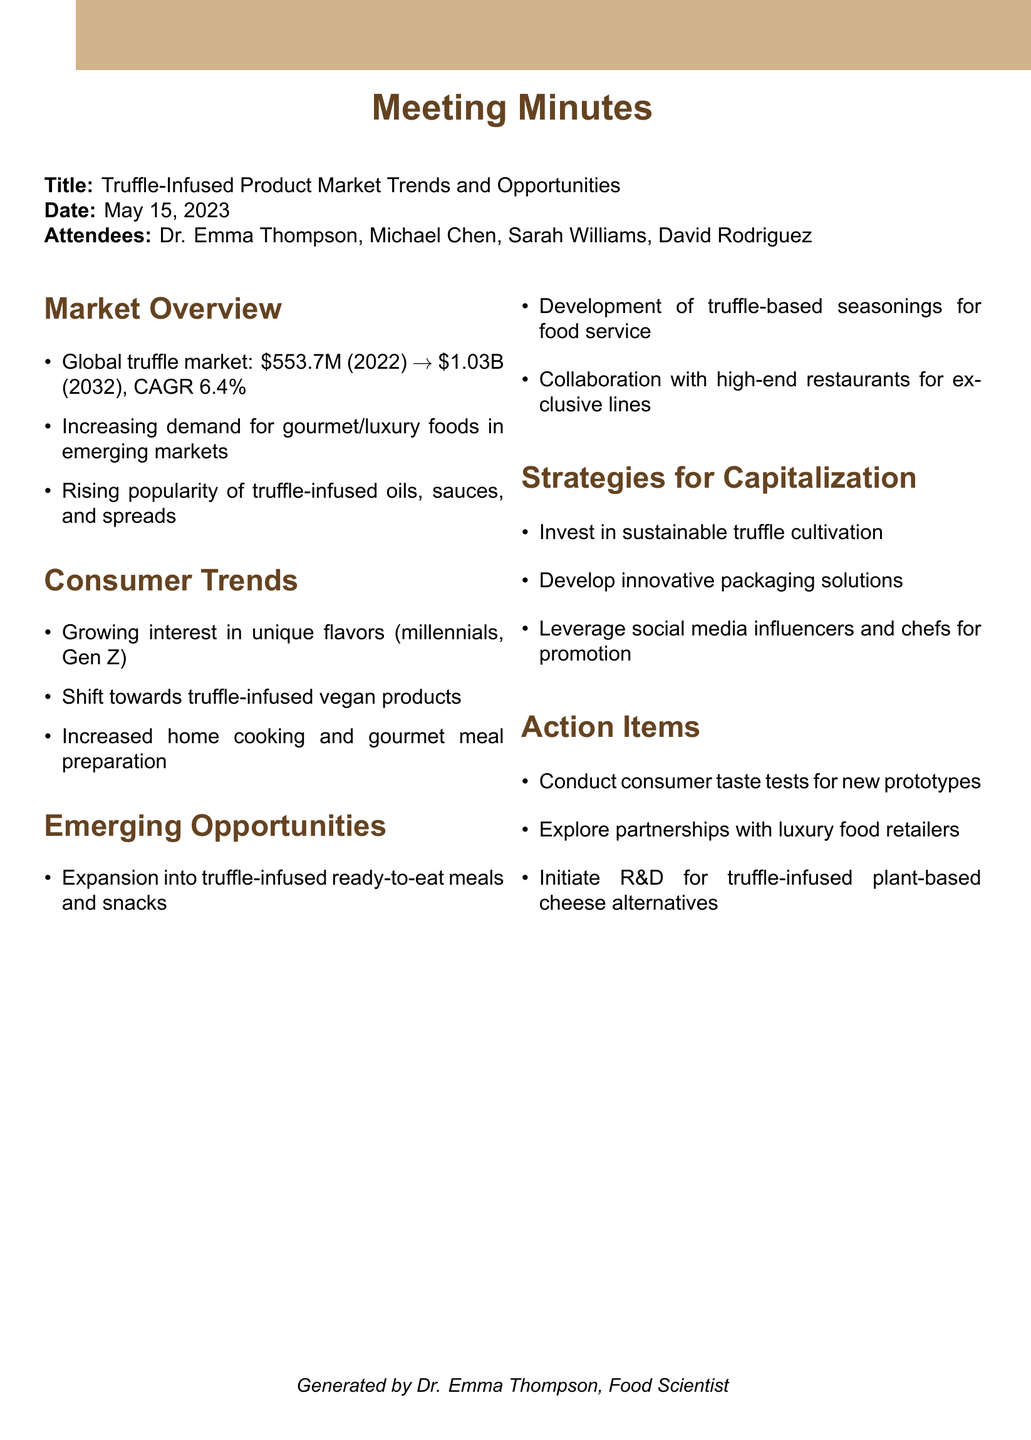What was the global truffle market value in 2022? The document states the global truffle market was valued at $553.7 million in 2022.
Answer: $553.7 million What is the projected CAGR for the truffle market from 2022 to 2032? The document indicates that the CAGR is expected to be 6.4%.
Answer: 6.4% Which demographics are showing a growing interest in unique flavors? According to the document, millennials and Gen Z are the demographics interested in unique flavors.
Answer: millennials and Gen Z What are potential product areas for truffle-infused innovations? The document lists ready-to-eat meals and snack foods as potential areas for innovation.
Answer: ready-to-eat meals and snack foods What is one strategy proposed for promoting truffle-infused products? The document suggests leveraging social media influencers and chefs as a promotional strategy.
Answer: social media influencers and chefs What action item involves testing new snack prototypes? The document includes conducting consumer taste tests for new truffle-infused snack prototypes.
Answer: consumer taste tests Who generated the meeting minutes? The document states that Dr. Emma Thompson generated the minutes.
Answer: Dr. Emma Thompson How many attendees were present at the meeting? The document lists a total of four attendees present.
Answer: four 